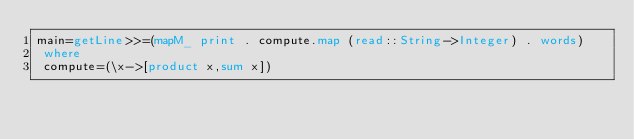<code> <loc_0><loc_0><loc_500><loc_500><_Haskell_>main=getLine>>=(mapM_ print . compute.map (read::String->Integer) . words)
 where
 compute=(\x->[product x,sum x])</code> 